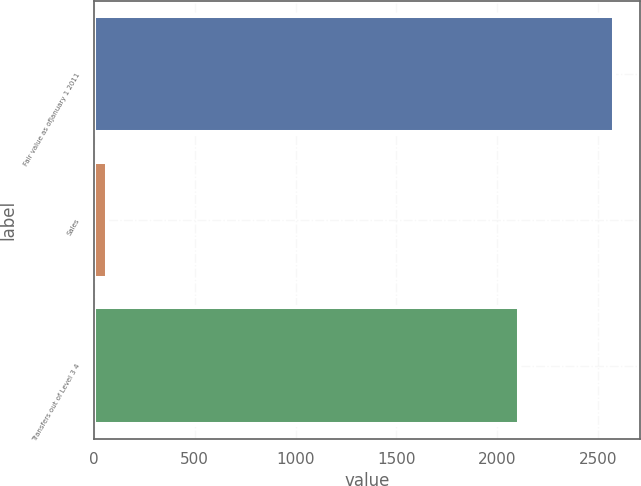<chart> <loc_0><loc_0><loc_500><loc_500><bar_chart><fcel>Fair value as ofJanuary 1 2011<fcel>Sales<fcel>Transfers out of Level 3 4<nl><fcel>2581<fcel>66<fcel>2111<nl></chart> 